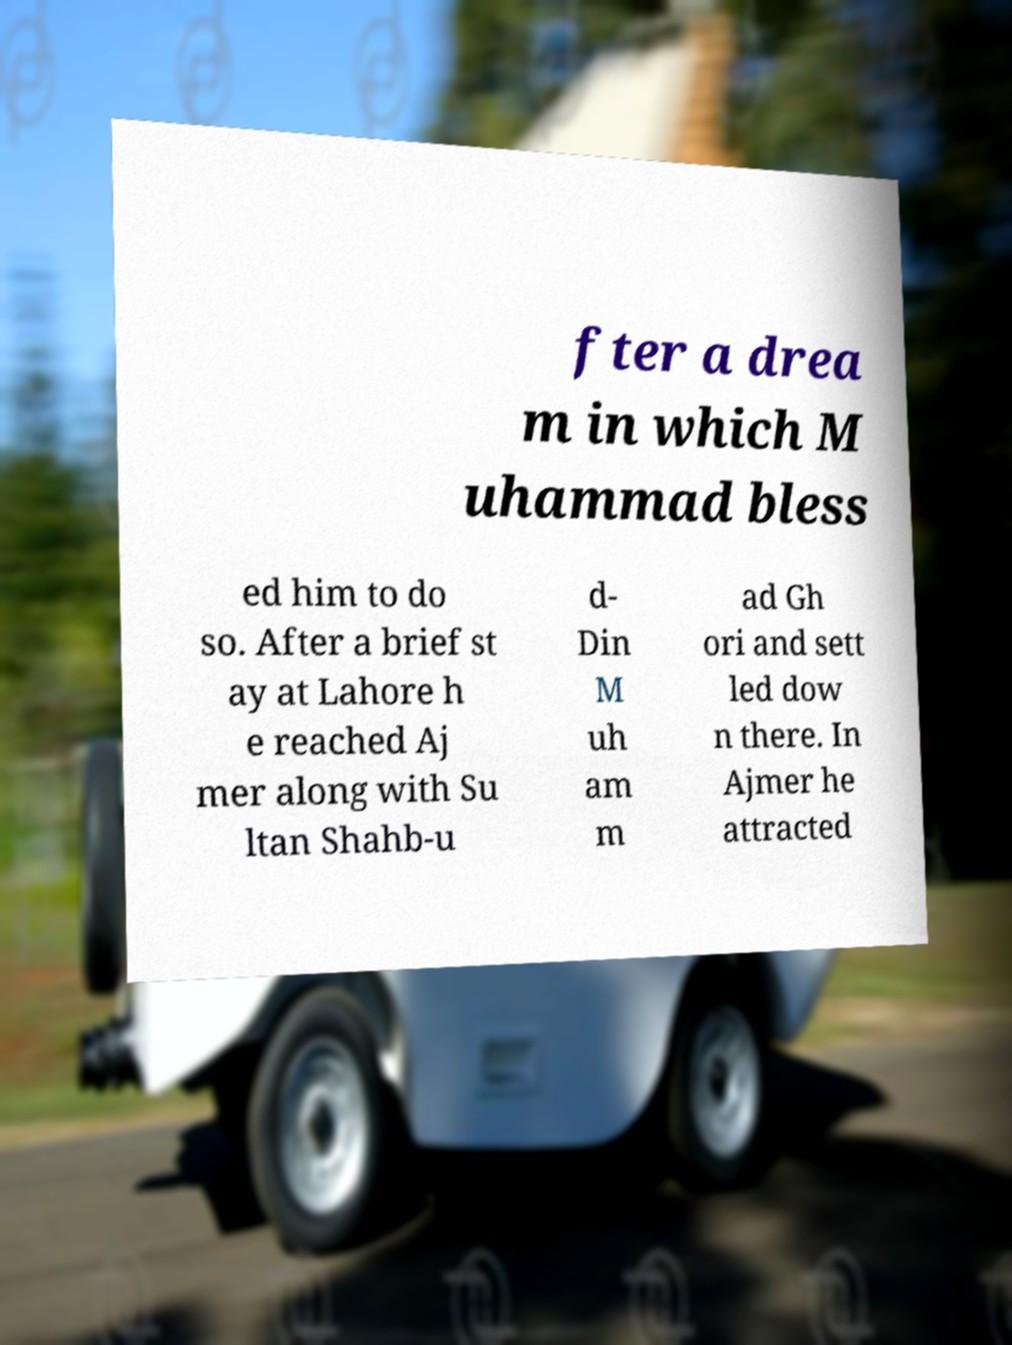Could you extract and type out the text from this image? fter a drea m in which M uhammad bless ed him to do so. After a brief st ay at Lahore h e reached Aj mer along with Su ltan Shahb-u d- Din M uh am m ad Gh ori and sett led dow n there. In Ajmer he attracted 